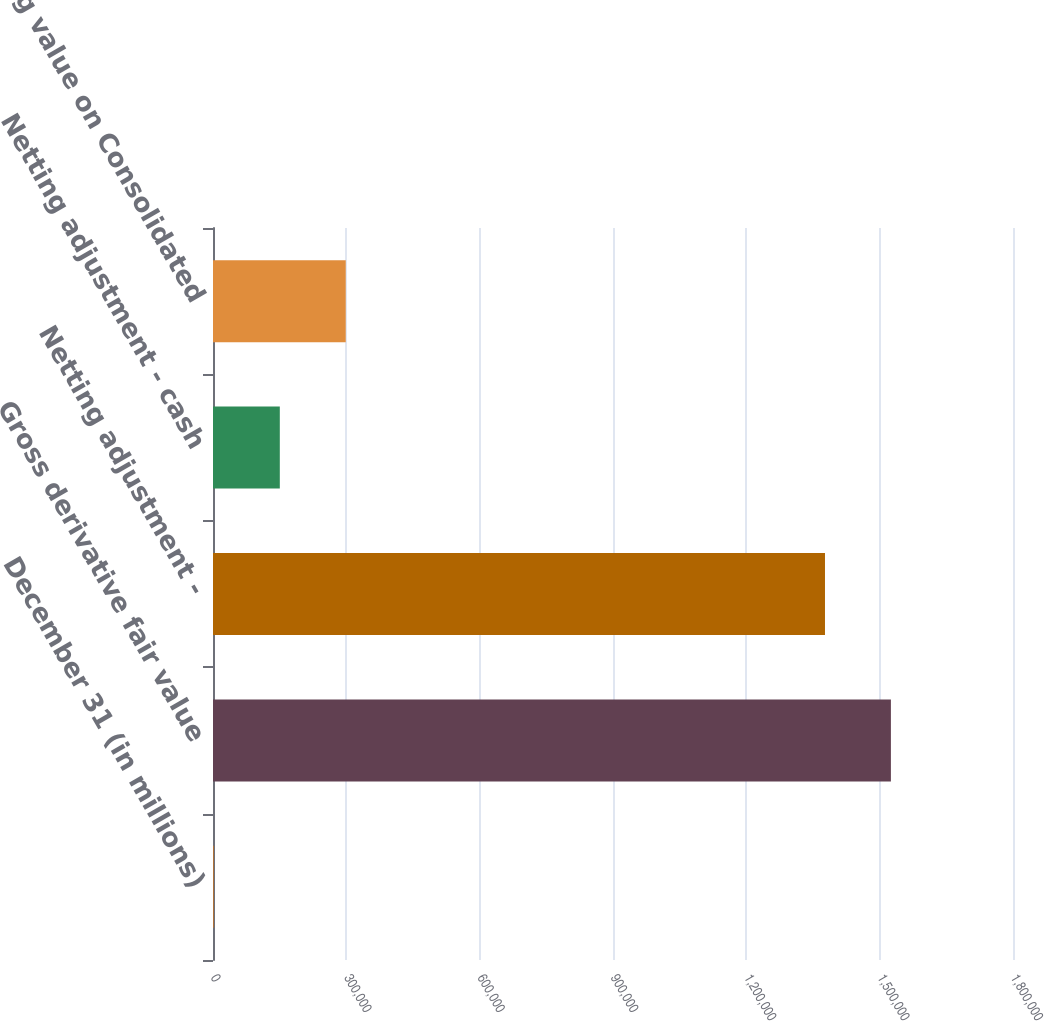Convert chart to OTSL. <chart><loc_0><loc_0><loc_500><loc_500><bar_chart><fcel>December 31 (in millions)<fcel>Gross derivative fair value<fcel>Netting adjustment -<fcel>Netting adjustment - cash<fcel>Carrying value on Consolidated<nl><fcel>2010<fcel>1.52528e+06<fcel>1.37697e+06<fcel>150320<fcel>298630<nl></chart> 